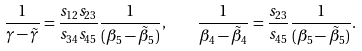<formula> <loc_0><loc_0><loc_500><loc_500>\frac { 1 } { \gamma - \tilde { \gamma } } = \frac { s _ { 1 2 } s _ { 2 3 } } { s _ { 3 4 } s _ { 4 5 } } \frac { 1 } { ( \beta _ { 5 } - \tilde { \beta } _ { 5 } ) } , \quad \frac { 1 } { \beta _ { 4 } - \tilde { \beta } _ { 4 } } = \frac { s _ { 2 3 } } { s _ { 4 5 } } \frac { 1 } { ( \beta _ { 5 } - \tilde { \beta } _ { 5 } ) } .</formula> 